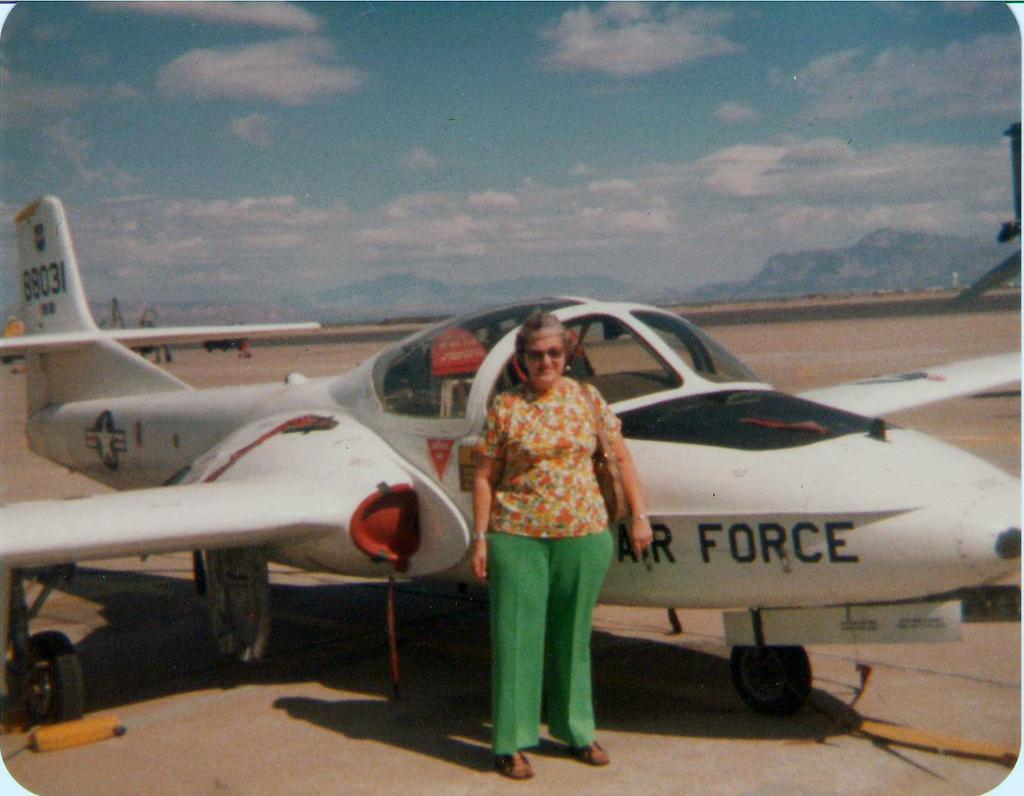What does it say on the side of the plane in the front?
Provide a succinct answer. Air force. 